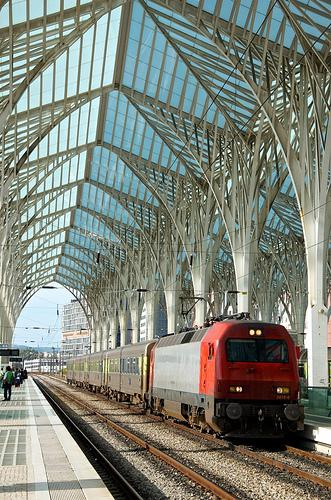Question: how many lights are there?
Choices:
A. Four.
B. Three.
C. Five.
D. Six.
Answer with the letter. Answer: A Question: what color is the train?
Choices:
A. Red.
B. White.
C. Blue.
D. Green.
Answer with the letter. Answer: A Question: what is material is covering the terminal?
Choices:
A. Wood.
B. Plastic.
C. Metal.
D. Cloth.
Answer with the letter. Answer: C Question: what is on the front of the train?
Choices:
A. Caboose.
B. Lights.
C. Flag.
D. Observation deck.
Answer with the letter. Answer: B Question: where is the train?
Choices:
A. At the train station.
B. On the rails.
C. Tracks.
D. On the railroad.
Answer with the letter. Answer: C 